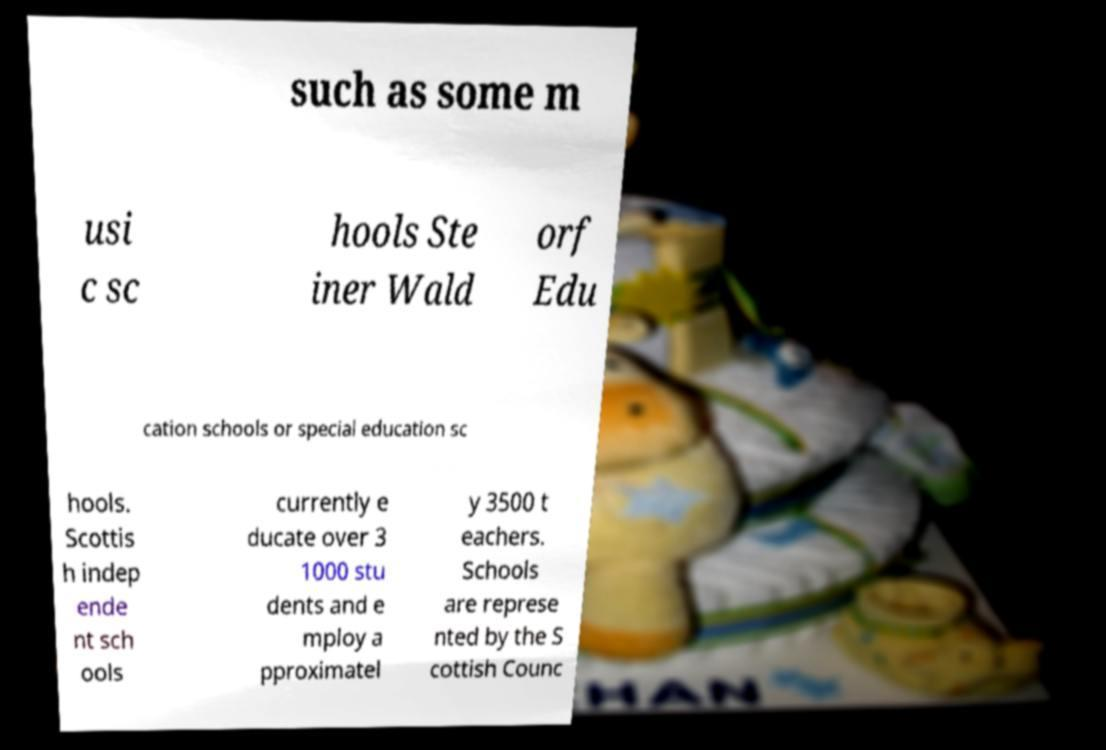What messages or text are displayed in this image? I need them in a readable, typed format. such as some m usi c sc hools Ste iner Wald orf Edu cation schools or special education sc hools. Scottis h indep ende nt sch ools currently e ducate over 3 1000 stu dents and e mploy a pproximatel y 3500 t eachers. Schools are represe nted by the S cottish Counc 